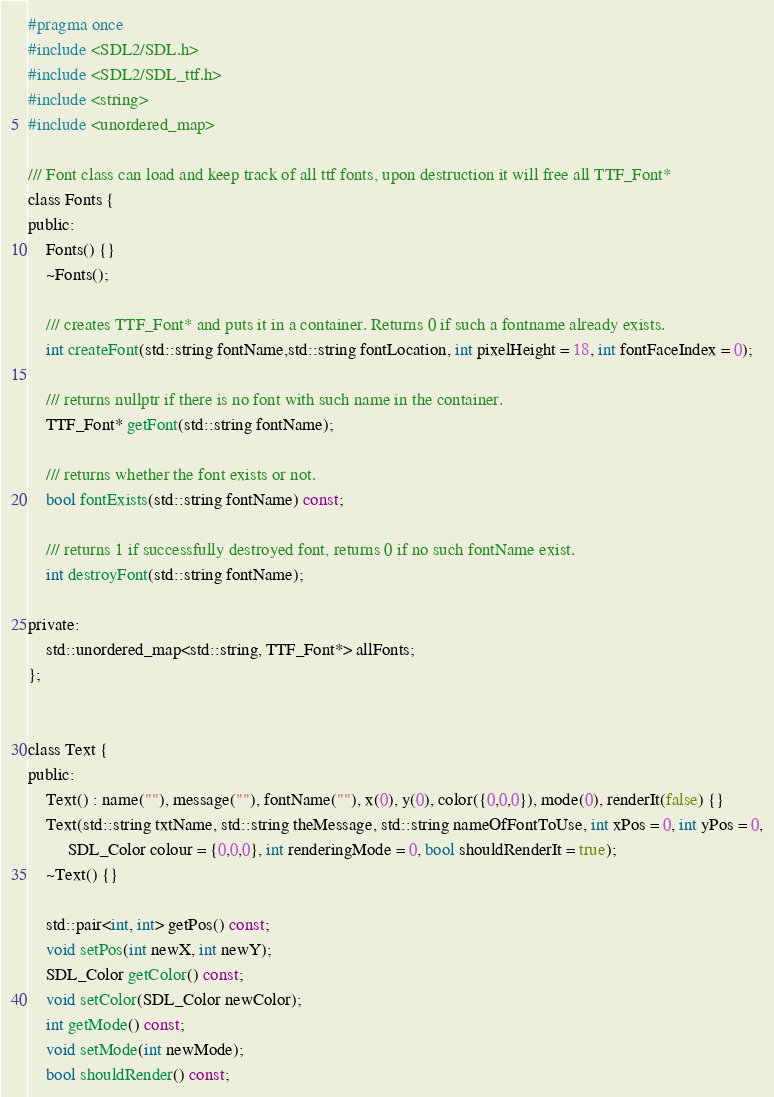<code> <loc_0><loc_0><loc_500><loc_500><_C_>#pragma once
#include <SDL2/SDL.h>
#include <SDL2/SDL_ttf.h>
#include <string>
#include <unordered_map>

/// Font class can load and keep track of all ttf fonts, upon destruction it will free all TTF_Font*
class Fonts {
public:
    Fonts() {}
    ~Fonts();

    /// creates TTF_Font* and puts it in a container. Returns 0 if such a fontname already exists.
    int createFont(std::string fontName,std::string fontLocation, int pixelHeight = 18, int fontFaceIndex = 0);

    /// returns nullptr if there is no font with such name in the container.
    TTF_Font* getFont(std::string fontName);

    /// returns whether the font exists or not.
    bool fontExists(std::string fontName) const;

    /// returns 1 if successfully destroyed font, returns 0 if no such fontName exist.
    int destroyFont(std::string fontName);

private:
    std::unordered_map<std::string, TTF_Font*> allFonts;
};


class Text {
public:
    Text() : name(""), message(""), fontName(""), x(0), y(0), color({0,0,0}), mode(0), renderIt(false) {}
    Text(std::string txtName, std::string theMessage, std::string nameOfFontToUse, int xPos = 0, int yPos = 0,
         SDL_Color colour = {0,0,0}, int renderingMode = 0, bool shouldRenderIt = true);
    ~Text() {}

    std::pair<int, int> getPos() const;
    void setPos(int newX, int newY);
    SDL_Color getColor() const;
    void setColor(SDL_Color newColor);
    int getMode() const;
    void setMode(int newMode);
    bool shouldRender() const;</code> 